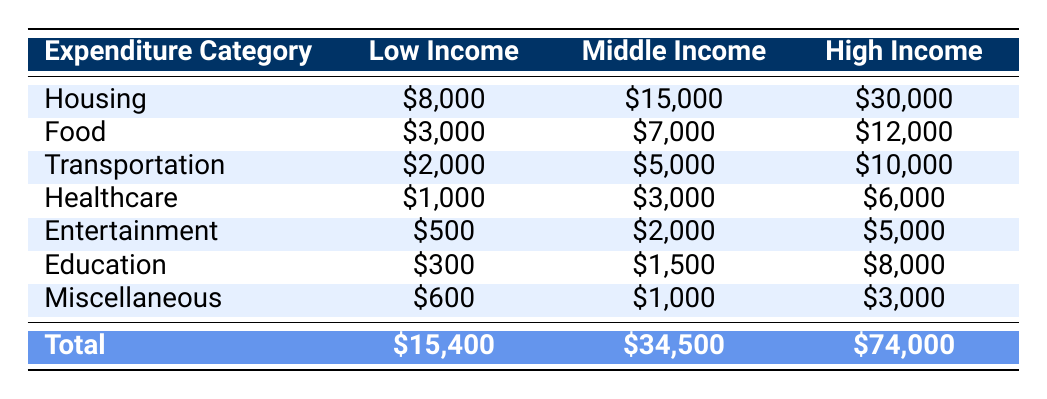What is the total expenditure for Low Income households in 2020? The total expenditure for Low Income households is provided in the table, which shows a total of $15,400. This value is found in the last row where the totals for each income level are displayed.
Answer: 15400 Which category had the highest expenditure for High Income households? By looking at the expenditures for High Income households, Housing has the highest expenditure at $30,000 when compared to other categories listed in that row.
Answer: 30000 What is the difference in expenditure on Food between Middle Income and Low Income households? The expenditure on Food for Middle Income households is $7,000 and for Low Income households is $3,000. The difference is calculated by subtracting the Low Income value from the Middle Income value: $7,000 - $3,000 = $4,000.
Answer: 4000 Is it true that High Income households spend more on Education than Middle Income households? From the table, High Income households spend $8,000 on Education while Middle Income households spend $1,500. Since $8,000 is greater than $1,500, the statement is true.
Answer: Yes What is the average expenditure on Entertainment across all income levels? The expenditures on Entertainment are $500 for Low Income, $2,000 for Middle Income, and $5,000 for High Income. First, we sum these values: $500 + $2,000 + $5,000 = $7,500. Then, we divide this sum by the number of income levels (3): $7,500 / 3 = $2,500.
Answer: 2500 What percentage of the total expenditure does Healthcare represent for Middle Income households? The total expenditure for Middle Income households is $34,500 and the expenditure on Healthcare is $3,000. To find the percentage, we calculate: ($3,000 / $34,500) * 100 = approximately 8.70%.
Answer: 8.7% Which income level spends the least on Transportation? The expenditures on Transportation are listed as $2,000 for Low Income, $5,000 for Middle Income, and $10,000 for High Income. The lowest value among these is $2,000, which corresponds to Low Income households.
Answer: 2000 What is the combined expenditure on Housing and Healthcare for High Income households compared to Low Income households? For High Income households, Housing expenditure is $30,000 and Healthcare expenditure is $6,000. For Low Income households, Housing is $8,000 and Healthcare is $1,000. The combined for High Income is $30,000 + $6,000 = $36,000, and for Low Income is $8,000 + $1,000 = $9,000. $36,000 is greater than $9,000, indicating High Income households spend more in total on these categories.
Answer: Yes 